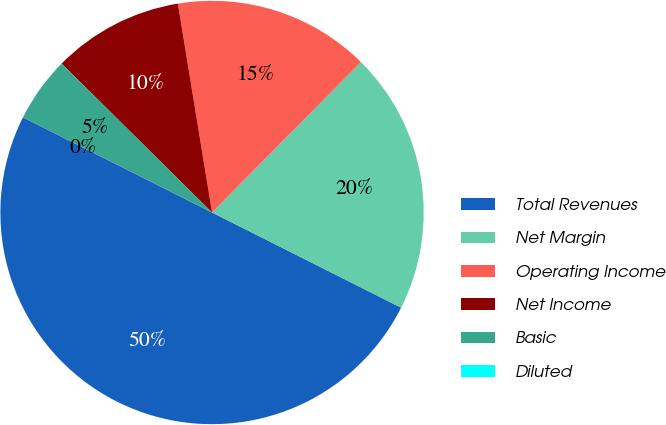Convert chart. <chart><loc_0><loc_0><loc_500><loc_500><pie_chart><fcel>Total Revenues<fcel>Net Margin<fcel>Operating Income<fcel>Net Income<fcel>Basic<fcel>Diluted<nl><fcel>50.0%<fcel>20.0%<fcel>15.0%<fcel>10.0%<fcel>5.0%<fcel>0.0%<nl></chart> 